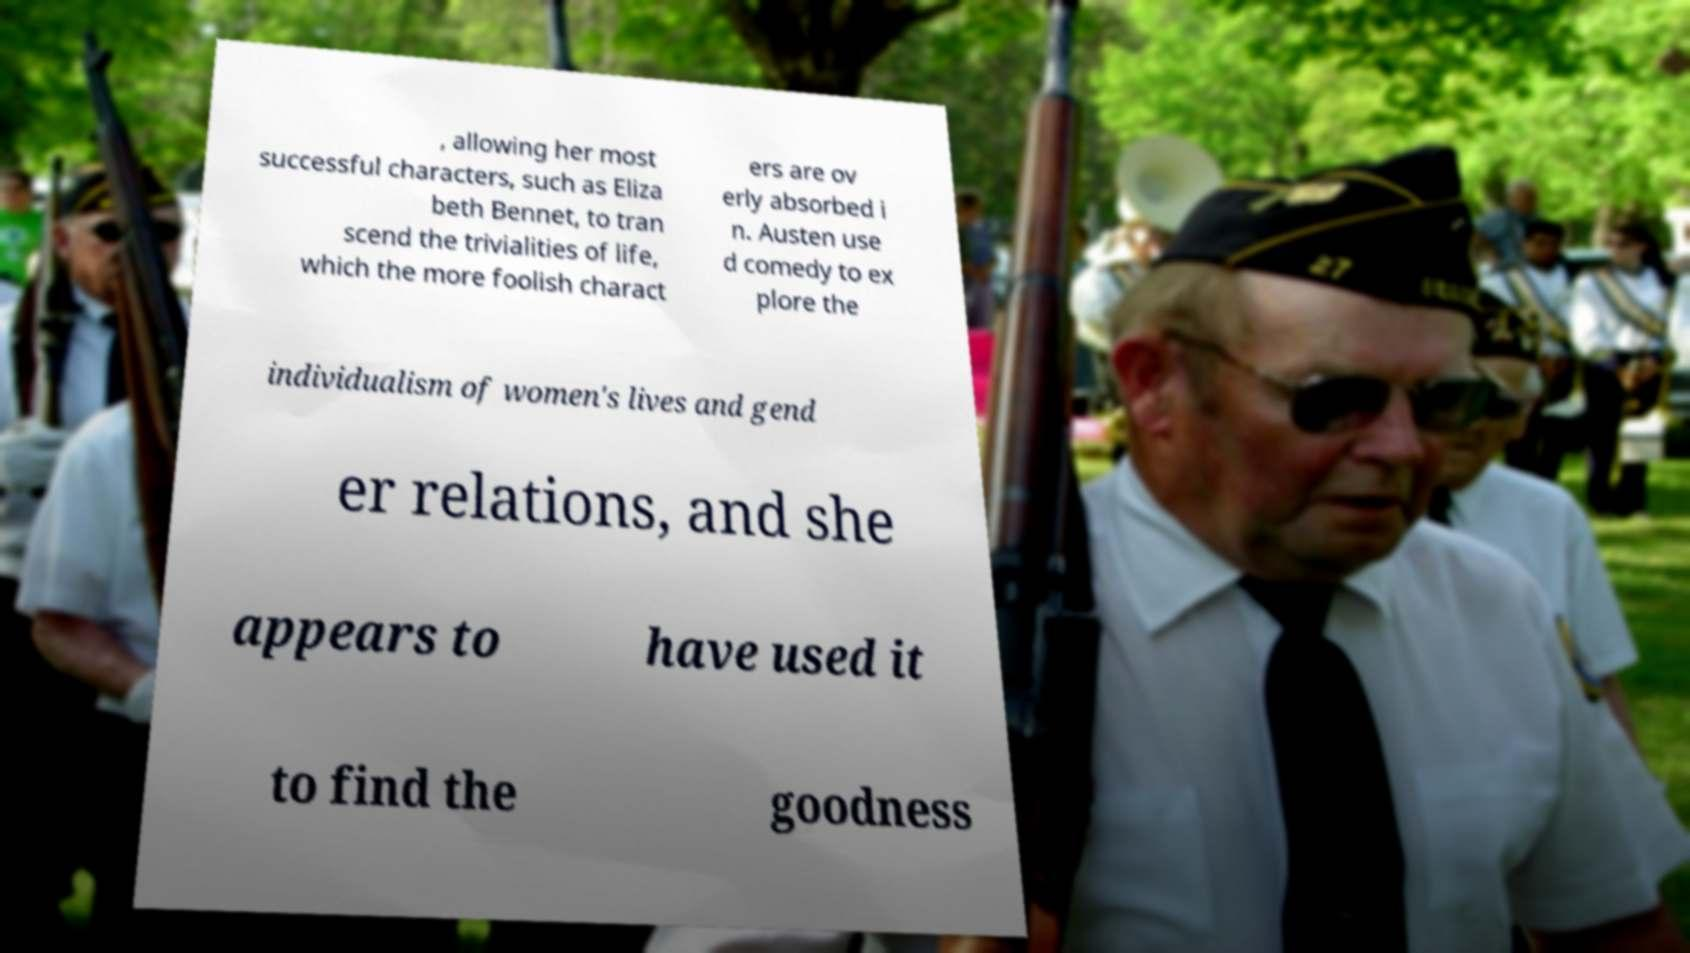Please read and relay the text visible in this image. What does it say? , allowing her most successful characters, such as Eliza beth Bennet, to tran scend the trivialities of life, which the more foolish charact ers are ov erly absorbed i n. Austen use d comedy to ex plore the individualism of women's lives and gend er relations, and she appears to have used it to find the goodness 